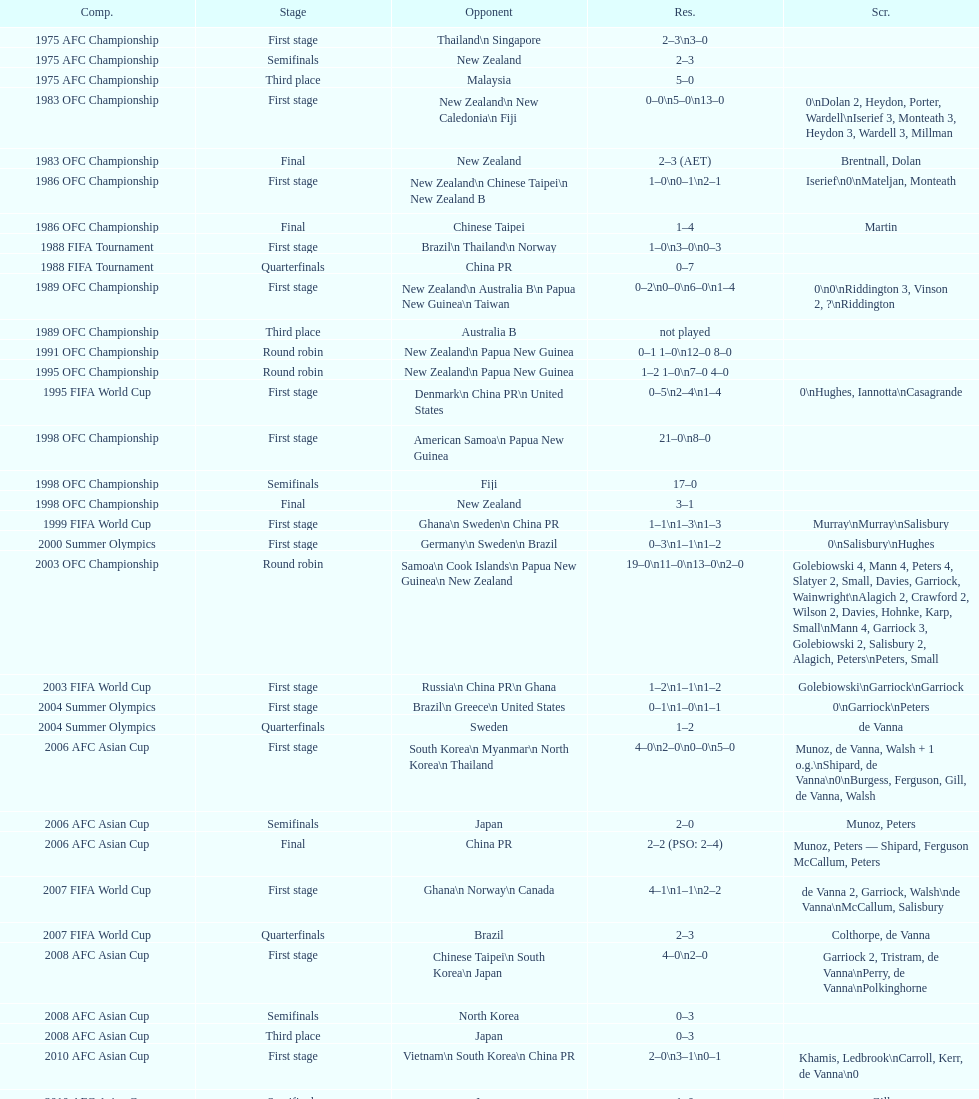What it the total number of countries in the first stage of the 2008 afc asian cup? 4. 